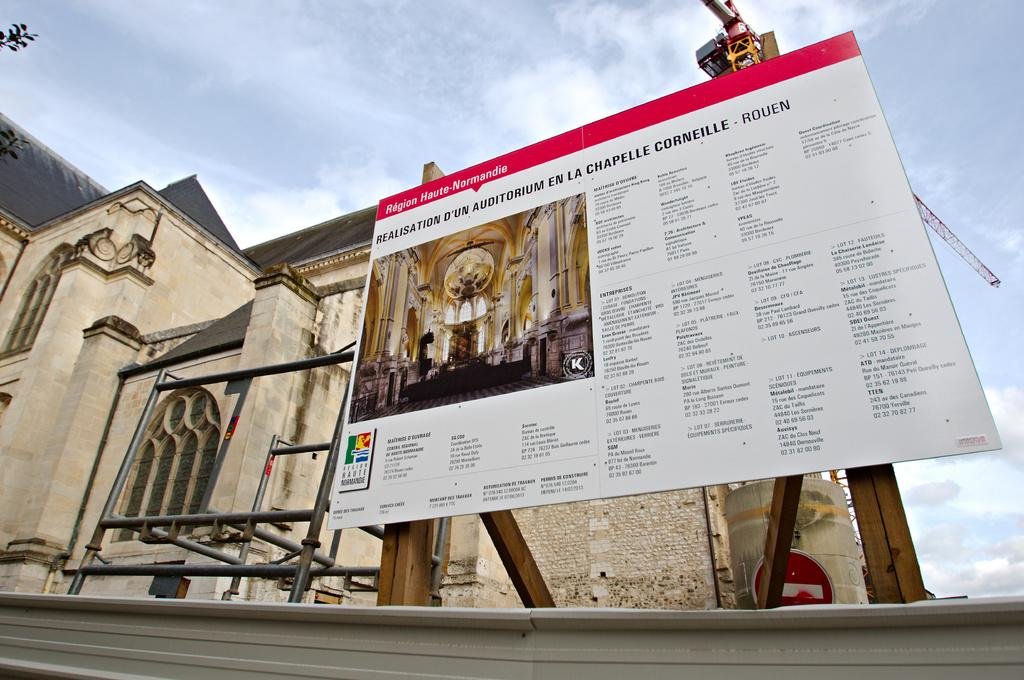<image>
Describe the image concisely. A billboard showing information about a cathedral, written in French. 